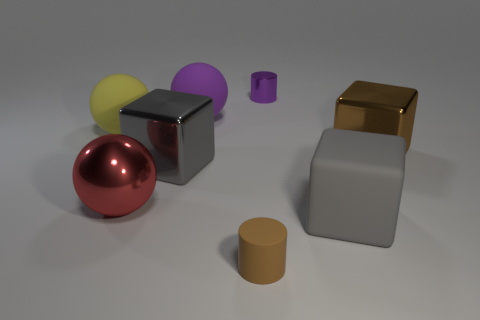Add 2 small purple metallic cylinders. How many objects exist? 10 Subtract all cylinders. How many objects are left? 6 Add 4 brown things. How many brown things are left? 6 Add 4 big purple matte objects. How many big purple matte objects exist? 5 Subtract 0 blue blocks. How many objects are left? 8 Subtract all tiny brown matte cylinders. Subtract all large gray blocks. How many objects are left? 5 